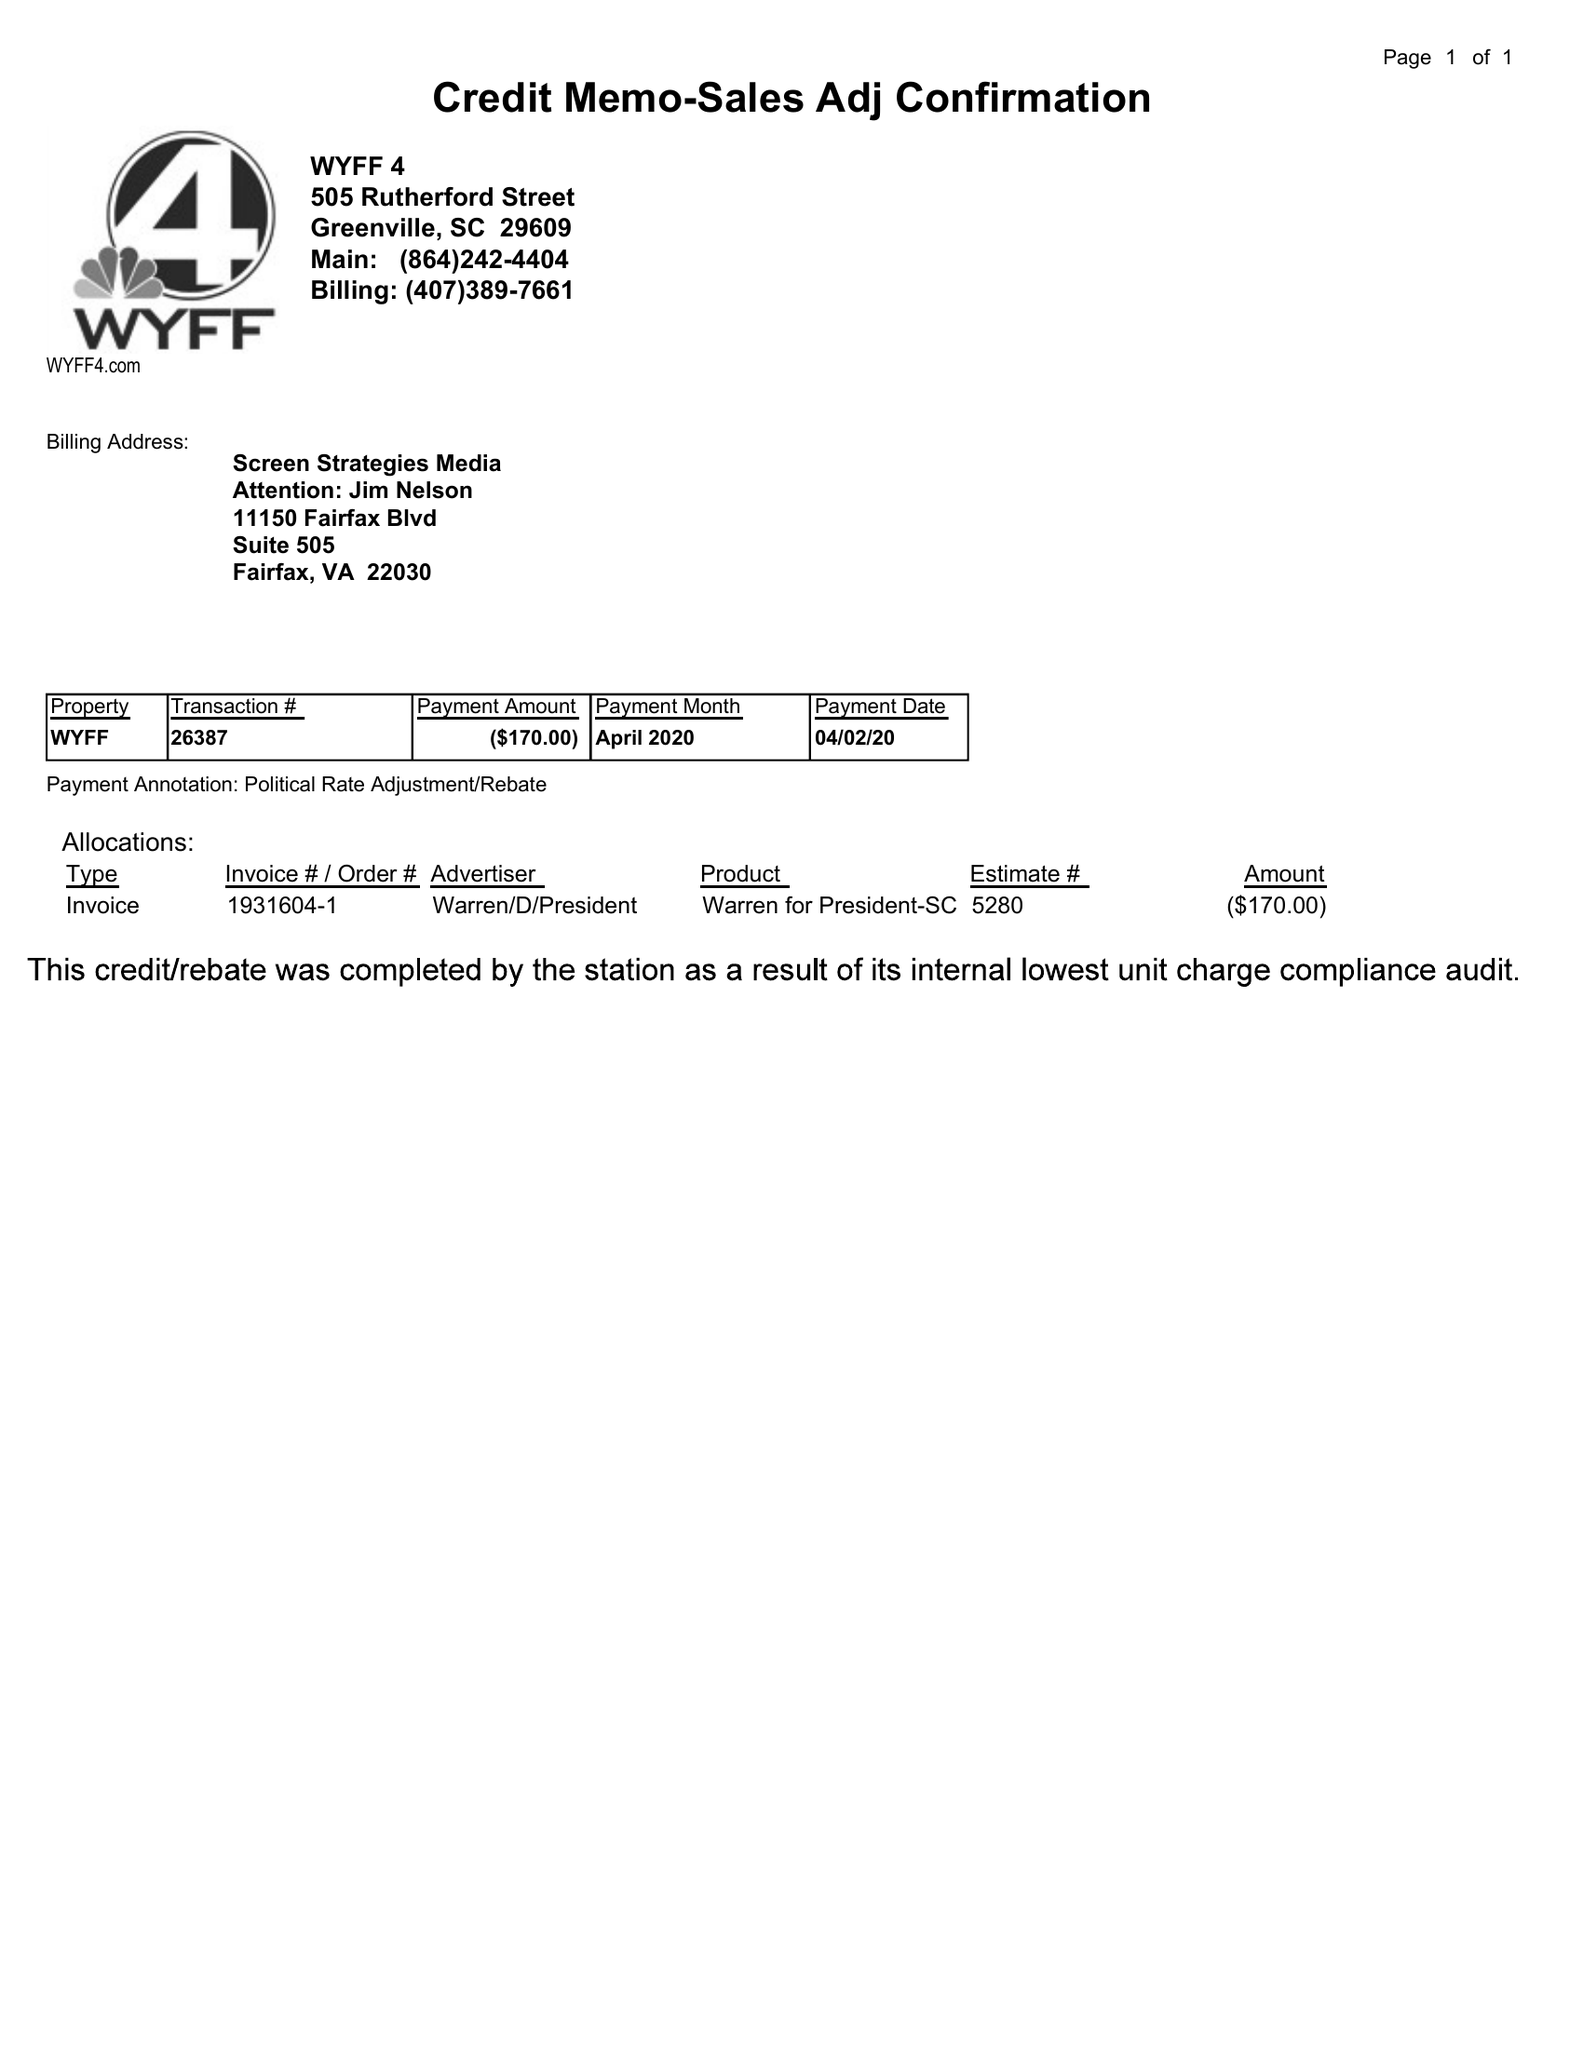What is the value for the contract_num?
Answer the question using a single word or phrase. None 